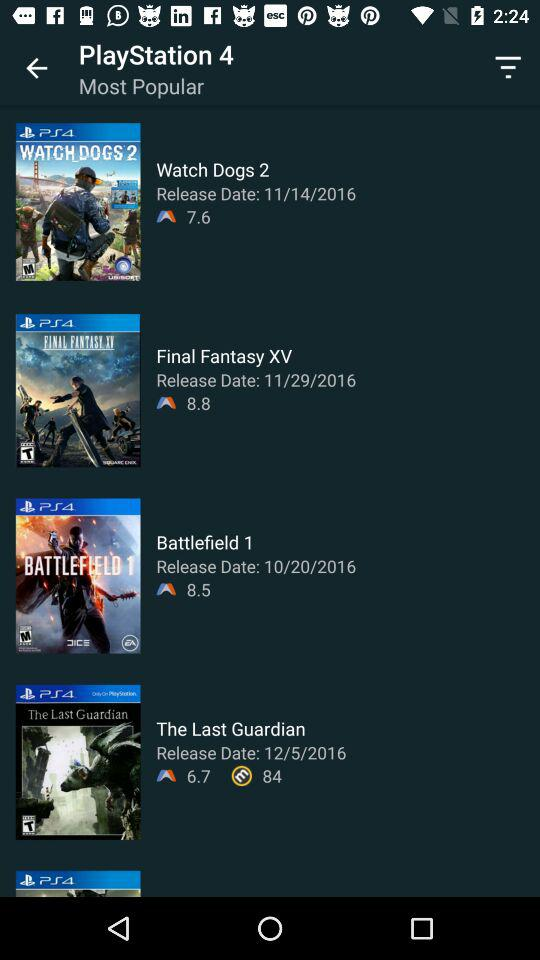What is the rating of "Watch Dogs 2"? The rating of "Watch Dogs 2" is 7.6. 